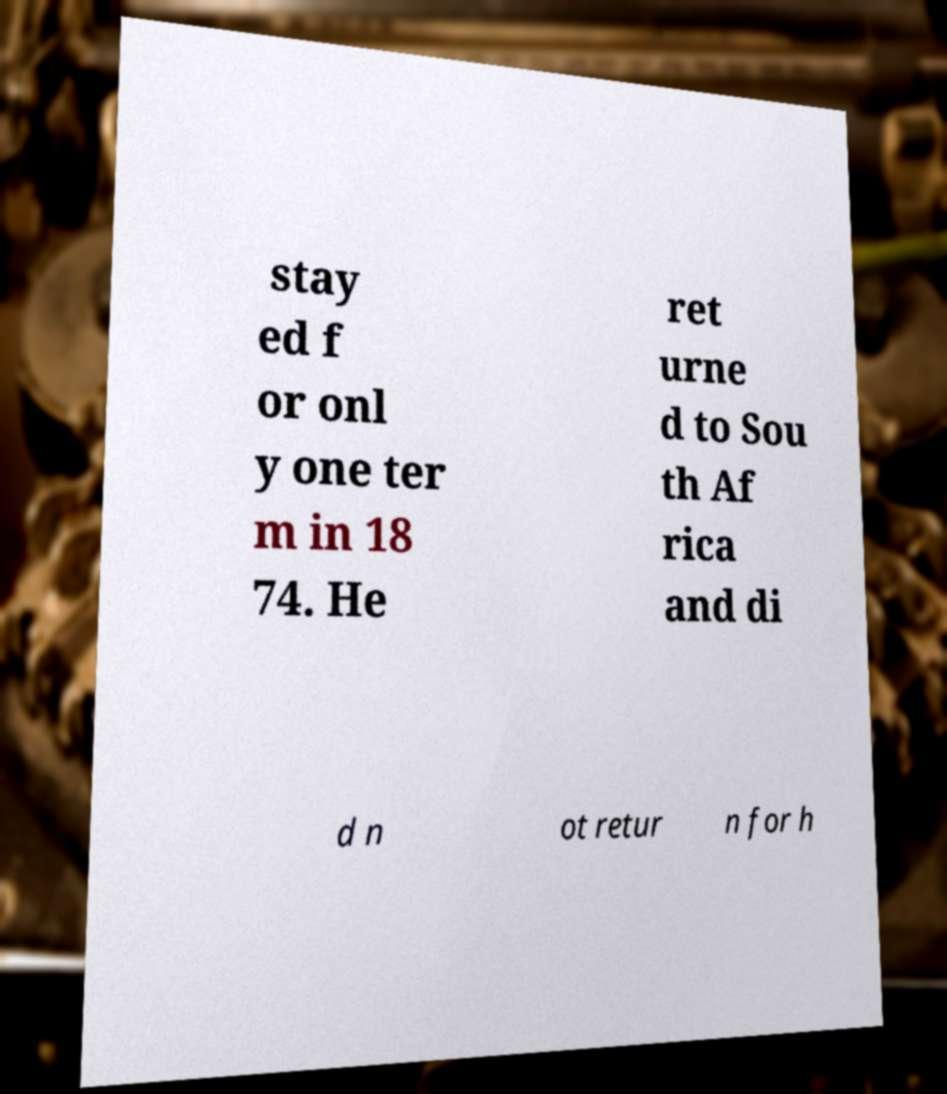Can you read and provide the text displayed in the image?This photo seems to have some interesting text. Can you extract and type it out for me? stay ed f or onl y one ter m in 18 74. He ret urne d to Sou th Af rica and di d n ot retur n for h 